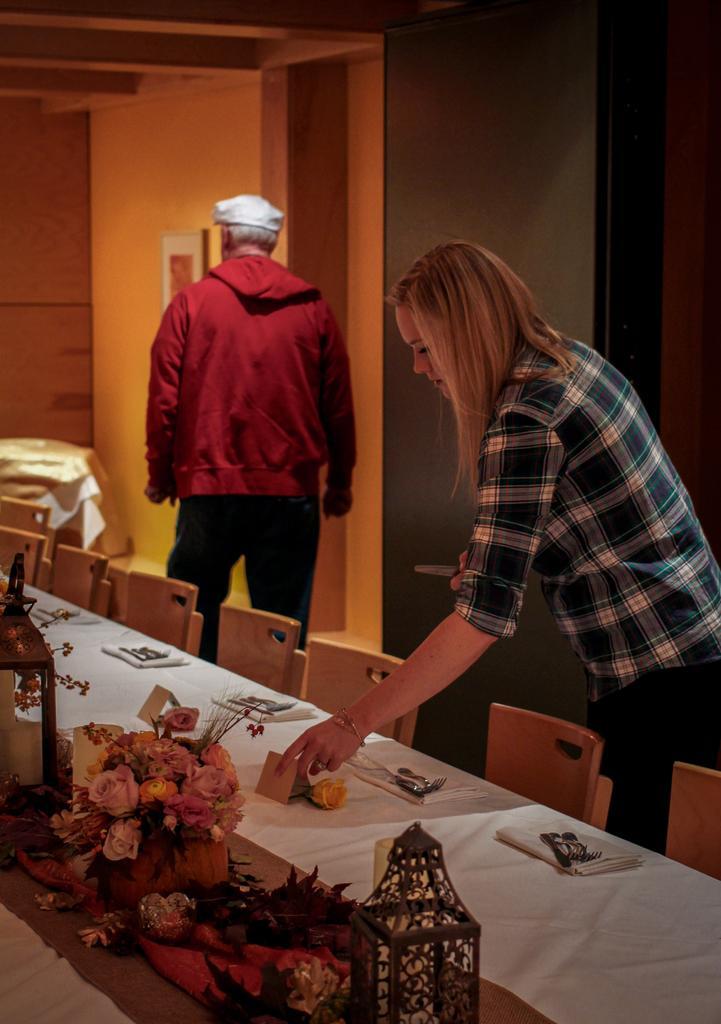Could you give a brief overview of what you see in this image? In this picture there is a woman keeping some objects on the table and there is a man standing behind her. 